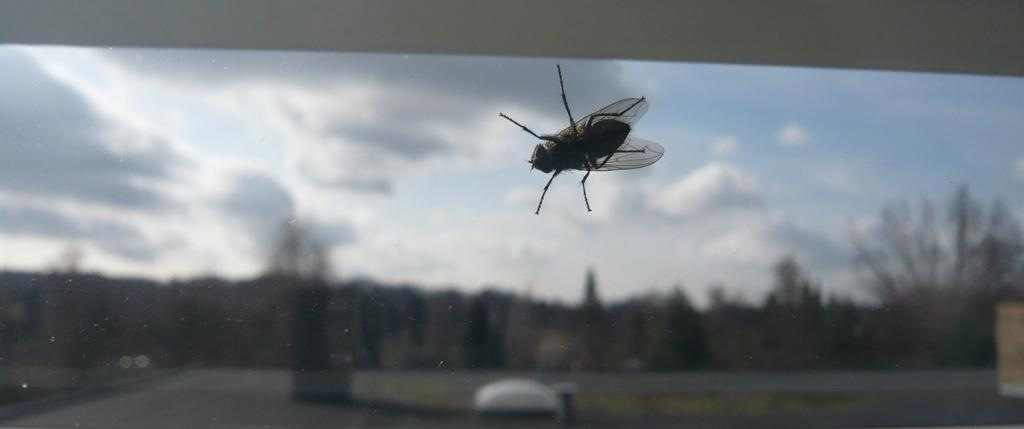What is in the foreground of the image? There is a glass window in the foreground of the image. What can be seen on the glass window? There is a bee on the window. What is visible in the background of the image? There are trees and a walkway in the background of the image. What type of coal can be seen in the image? There is no coal present in the image. What is the relation between the bee and the walkway in the image? The image does not show a direct relation between the bee and the walkway; they are simply separate elements in the scene. 